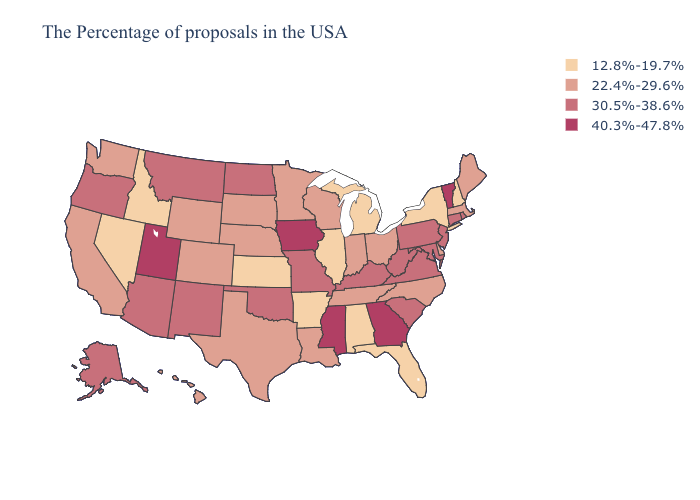What is the value of New York?
Quick response, please. 12.8%-19.7%. What is the lowest value in the USA?
Write a very short answer. 12.8%-19.7%. Name the states that have a value in the range 30.5%-38.6%?
Be succinct. Rhode Island, Connecticut, New Jersey, Maryland, Pennsylvania, Virginia, South Carolina, West Virginia, Kentucky, Missouri, Oklahoma, North Dakota, New Mexico, Montana, Arizona, Oregon, Alaska. Among the states that border Iowa , which have the lowest value?
Quick response, please. Illinois. Does the first symbol in the legend represent the smallest category?
Be succinct. Yes. What is the lowest value in the USA?
Keep it brief. 12.8%-19.7%. Does Utah have a lower value than Connecticut?
Concise answer only. No. What is the lowest value in the South?
Short answer required. 12.8%-19.7%. Does Hawaii have a lower value than Montana?
Be succinct. Yes. Which states hav the highest value in the MidWest?
Quick response, please. Iowa. What is the value of New Mexico?
Quick response, please. 30.5%-38.6%. Among the states that border South Carolina , which have the highest value?
Quick response, please. Georgia. What is the value of Hawaii?
Answer briefly. 22.4%-29.6%. What is the value of Washington?
Be succinct. 22.4%-29.6%. What is the highest value in the South ?
Short answer required. 40.3%-47.8%. 